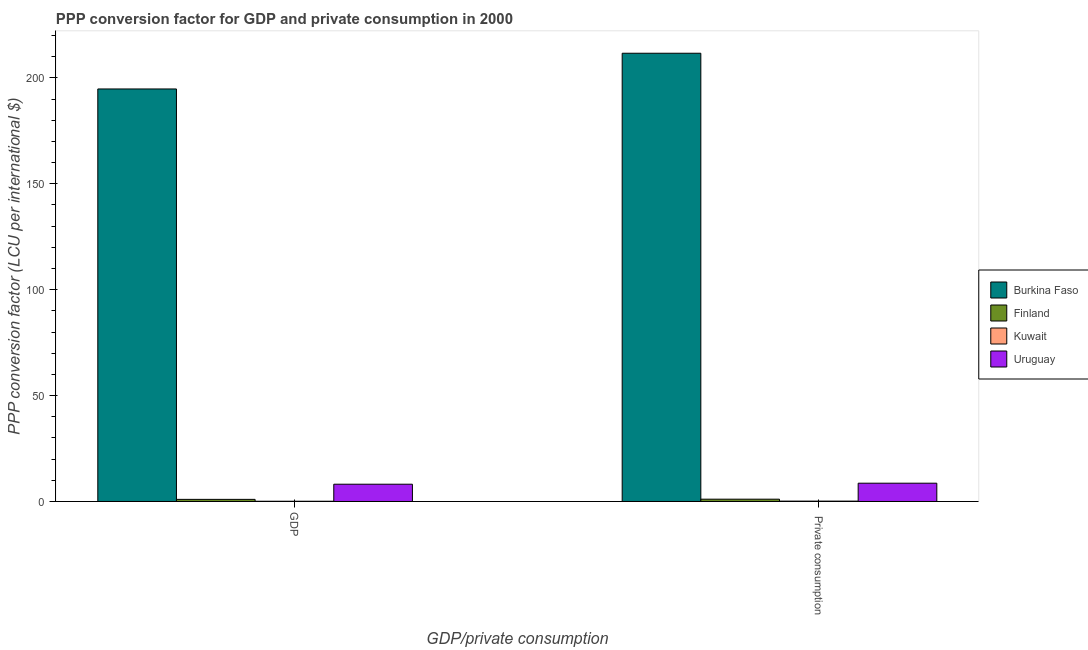How many different coloured bars are there?
Ensure brevity in your answer.  4. How many groups of bars are there?
Your answer should be very brief. 2. How many bars are there on the 1st tick from the left?
Offer a very short reply. 4. What is the label of the 1st group of bars from the left?
Offer a very short reply. GDP. What is the ppp conversion factor for gdp in Burkina Faso?
Provide a succinct answer. 194.77. Across all countries, what is the maximum ppp conversion factor for gdp?
Your response must be concise. 194.77. Across all countries, what is the minimum ppp conversion factor for gdp?
Offer a terse response. 0.1. In which country was the ppp conversion factor for private consumption maximum?
Provide a succinct answer. Burkina Faso. In which country was the ppp conversion factor for gdp minimum?
Provide a succinct answer. Kuwait. What is the total ppp conversion factor for gdp in the graph?
Ensure brevity in your answer.  204.02. What is the difference between the ppp conversion factor for gdp in Kuwait and that in Uruguay?
Provide a short and direct response. -8.05. What is the difference between the ppp conversion factor for gdp in Kuwait and the ppp conversion factor for private consumption in Finland?
Your response must be concise. -0.98. What is the average ppp conversion factor for gdp per country?
Provide a short and direct response. 51. What is the difference between the ppp conversion factor for gdp and ppp conversion factor for private consumption in Burkina Faso?
Offer a terse response. -16.87. In how many countries, is the ppp conversion factor for private consumption greater than 110 LCU?
Offer a terse response. 1. What is the ratio of the ppp conversion factor for private consumption in Finland to that in Burkina Faso?
Give a very brief answer. 0.01. Is the ppp conversion factor for private consumption in Finland less than that in Kuwait?
Offer a terse response. No. What does the 3rd bar from the left in  Private consumption represents?
Provide a succinct answer. Kuwait. What does the 2nd bar from the right in  Private consumption represents?
Your answer should be very brief. Kuwait. How many bars are there?
Your answer should be very brief. 8. Are all the bars in the graph horizontal?
Provide a succinct answer. No. How many countries are there in the graph?
Your response must be concise. 4. What is the difference between two consecutive major ticks on the Y-axis?
Offer a very short reply. 50. Are the values on the major ticks of Y-axis written in scientific E-notation?
Give a very brief answer. No. Does the graph contain grids?
Your answer should be very brief. No. Where does the legend appear in the graph?
Ensure brevity in your answer.  Center right. How are the legend labels stacked?
Provide a succinct answer. Vertical. What is the title of the graph?
Your response must be concise. PPP conversion factor for GDP and private consumption in 2000. Does "South Sudan" appear as one of the legend labels in the graph?
Your answer should be very brief. No. What is the label or title of the X-axis?
Provide a short and direct response. GDP/private consumption. What is the label or title of the Y-axis?
Give a very brief answer. PPP conversion factor (LCU per international $). What is the PPP conversion factor (LCU per international $) in Burkina Faso in GDP?
Ensure brevity in your answer.  194.77. What is the PPP conversion factor (LCU per international $) of Finland in GDP?
Provide a succinct answer. 0.99. What is the PPP conversion factor (LCU per international $) of Kuwait in GDP?
Provide a succinct answer. 0.1. What is the PPP conversion factor (LCU per international $) of Uruguay in GDP?
Your answer should be compact. 8.15. What is the PPP conversion factor (LCU per international $) of Burkina Faso in  Private consumption?
Provide a succinct answer. 211.64. What is the PPP conversion factor (LCU per international $) in Finland in  Private consumption?
Your answer should be compact. 1.08. What is the PPP conversion factor (LCU per international $) of Kuwait in  Private consumption?
Make the answer very short. 0.16. What is the PPP conversion factor (LCU per international $) in Uruguay in  Private consumption?
Ensure brevity in your answer.  8.63. Across all GDP/private consumption, what is the maximum PPP conversion factor (LCU per international $) of Burkina Faso?
Your response must be concise. 211.64. Across all GDP/private consumption, what is the maximum PPP conversion factor (LCU per international $) in Finland?
Offer a terse response. 1.08. Across all GDP/private consumption, what is the maximum PPP conversion factor (LCU per international $) of Kuwait?
Give a very brief answer. 0.16. Across all GDP/private consumption, what is the maximum PPP conversion factor (LCU per international $) in Uruguay?
Make the answer very short. 8.63. Across all GDP/private consumption, what is the minimum PPP conversion factor (LCU per international $) of Burkina Faso?
Provide a short and direct response. 194.77. Across all GDP/private consumption, what is the minimum PPP conversion factor (LCU per international $) in Finland?
Keep it short and to the point. 0.99. Across all GDP/private consumption, what is the minimum PPP conversion factor (LCU per international $) of Kuwait?
Keep it short and to the point. 0.1. Across all GDP/private consumption, what is the minimum PPP conversion factor (LCU per international $) of Uruguay?
Offer a very short reply. 8.15. What is the total PPP conversion factor (LCU per international $) of Burkina Faso in the graph?
Provide a short and direct response. 406.42. What is the total PPP conversion factor (LCU per international $) in Finland in the graph?
Ensure brevity in your answer.  2.08. What is the total PPP conversion factor (LCU per international $) in Kuwait in the graph?
Give a very brief answer. 0.26. What is the total PPP conversion factor (LCU per international $) in Uruguay in the graph?
Provide a succinct answer. 16.78. What is the difference between the PPP conversion factor (LCU per international $) of Burkina Faso in GDP and that in  Private consumption?
Provide a short and direct response. -16.87. What is the difference between the PPP conversion factor (LCU per international $) in Finland in GDP and that in  Private consumption?
Your answer should be very brief. -0.09. What is the difference between the PPP conversion factor (LCU per international $) of Kuwait in GDP and that in  Private consumption?
Offer a terse response. -0.06. What is the difference between the PPP conversion factor (LCU per international $) of Uruguay in GDP and that in  Private consumption?
Ensure brevity in your answer.  -0.48. What is the difference between the PPP conversion factor (LCU per international $) of Burkina Faso in GDP and the PPP conversion factor (LCU per international $) of Finland in  Private consumption?
Give a very brief answer. 193.69. What is the difference between the PPP conversion factor (LCU per international $) in Burkina Faso in GDP and the PPP conversion factor (LCU per international $) in Kuwait in  Private consumption?
Make the answer very short. 194.62. What is the difference between the PPP conversion factor (LCU per international $) of Burkina Faso in GDP and the PPP conversion factor (LCU per international $) of Uruguay in  Private consumption?
Your response must be concise. 186.15. What is the difference between the PPP conversion factor (LCU per international $) of Finland in GDP and the PPP conversion factor (LCU per international $) of Kuwait in  Private consumption?
Offer a very short reply. 0.84. What is the difference between the PPP conversion factor (LCU per international $) of Finland in GDP and the PPP conversion factor (LCU per international $) of Uruguay in  Private consumption?
Your answer should be very brief. -7.63. What is the difference between the PPP conversion factor (LCU per international $) of Kuwait in GDP and the PPP conversion factor (LCU per international $) of Uruguay in  Private consumption?
Offer a very short reply. -8.53. What is the average PPP conversion factor (LCU per international $) of Burkina Faso per GDP/private consumption?
Give a very brief answer. 203.21. What is the average PPP conversion factor (LCU per international $) of Finland per GDP/private consumption?
Your answer should be very brief. 1.04. What is the average PPP conversion factor (LCU per international $) in Kuwait per GDP/private consumption?
Your response must be concise. 0.13. What is the average PPP conversion factor (LCU per international $) of Uruguay per GDP/private consumption?
Make the answer very short. 8.39. What is the difference between the PPP conversion factor (LCU per international $) in Burkina Faso and PPP conversion factor (LCU per international $) in Finland in GDP?
Your response must be concise. 193.78. What is the difference between the PPP conversion factor (LCU per international $) of Burkina Faso and PPP conversion factor (LCU per international $) of Kuwait in GDP?
Provide a short and direct response. 194.67. What is the difference between the PPP conversion factor (LCU per international $) of Burkina Faso and PPP conversion factor (LCU per international $) of Uruguay in GDP?
Make the answer very short. 186.63. What is the difference between the PPP conversion factor (LCU per international $) in Finland and PPP conversion factor (LCU per international $) in Kuwait in GDP?
Ensure brevity in your answer.  0.89. What is the difference between the PPP conversion factor (LCU per international $) in Finland and PPP conversion factor (LCU per international $) in Uruguay in GDP?
Your response must be concise. -7.15. What is the difference between the PPP conversion factor (LCU per international $) of Kuwait and PPP conversion factor (LCU per international $) of Uruguay in GDP?
Make the answer very short. -8.05. What is the difference between the PPP conversion factor (LCU per international $) in Burkina Faso and PPP conversion factor (LCU per international $) in Finland in  Private consumption?
Your answer should be very brief. 210.56. What is the difference between the PPP conversion factor (LCU per international $) in Burkina Faso and PPP conversion factor (LCU per international $) in Kuwait in  Private consumption?
Provide a succinct answer. 211.49. What is the difference between the PPP conversion factor (LCU per international $) in Burkina Faso and PPP conversion factor (LCU per international $) in Uruguay in  Private consumption?
Make the answer very short. 203.02. What is the difference between the PPP conversion factor (LCU per international $) in Finland and PPP conversion factor (LCU per international $) in Kuwait in  Private consumption?
Provide a short and direct response. 0.92. What is the difference between the PPP conversion factor (LCU per international $) in Finland and PPP conversion factor (LCU per international $) in Uruguay in  Private consumption?
Give a very brief answer. -7.55. What is the difference between the PPP conversion factor (LCU per international $) of Kuwait and PPP conversion factor (LCU per international $) of Uruguay in  Private consumption?
Your answer should be compact. -8.47. What is the ratio of the PPP conversion factor (LCU per international $) of Burkina Faso in GDP to that in  Private consumption?
Your response must be concise. 0.92. What is the ratio of the PPP conversion factor (LCU per international $) of Finland in GDP to that in  Private consumption?
Provide a succinct answer. 0.92. What is the ratio of the PPP conversion factor (LCU per international $) in Kuwait in GDP to that in  Private consumption?
Provide a succinct answer. 0.65. What is the ratio of the PPP conversion factor (LCU per international $) of Uruguay in GDP to that in  Private consumption?
Give a very brief answer. 0.94. What is the difference between the highest and the second highest PPP conversion factor (LCU per international $) in Burkina Faso?
Make the answer very short. 16.87. What is the difference between the highest and the second highest PPP conversion factor (LCU per international $) in Finland?
Your answer should be compact. 0.09. What is the difference between the highest and the second highest PPP conversion factor (LCU per international $) in Kuwait?
Provide a short and direct response. 0.06. What is the difference between the highest and the second highest PPP conversion factor (LCU per international $) of Uruguay?
Offer a very short reply. 0.48. What is the difference between the highest and the lowest PPP conversion factor (LCU per international $) of Burkina Faso?
Your answer should be compact. 16.87. What is the difference between the highest and the lowest PPP conversion factor (LCU per international $) in Finland?
Your answer should be compact. 0.09. What is the difference between the highest and the lowest PPP conversion factor (LCU per international $) in Kuwait?
Provide a succinct answer. 0.06. What is the difference between the highest and the lowest PPP conversion factor (LCU per international $) of Uruguay?
Your answer should be compact. 0.48. 